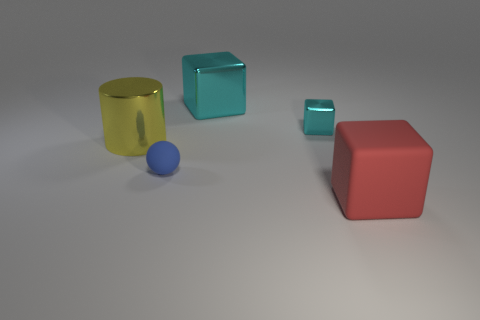Add 5 small green matte objects. How many objects exist? 10 Subtract all cylinders. How many objects are left? 4 Add 3 big cylinders. How many big cylinders exist? 4 Subtract 0 red cylinders. How many objects are left? 5 Subtract all small blue objects. Subtract all tiny metallic blocks. How many objects are left? 3 Add 2 big cyan objects. How many big cyan objects are left? 3 